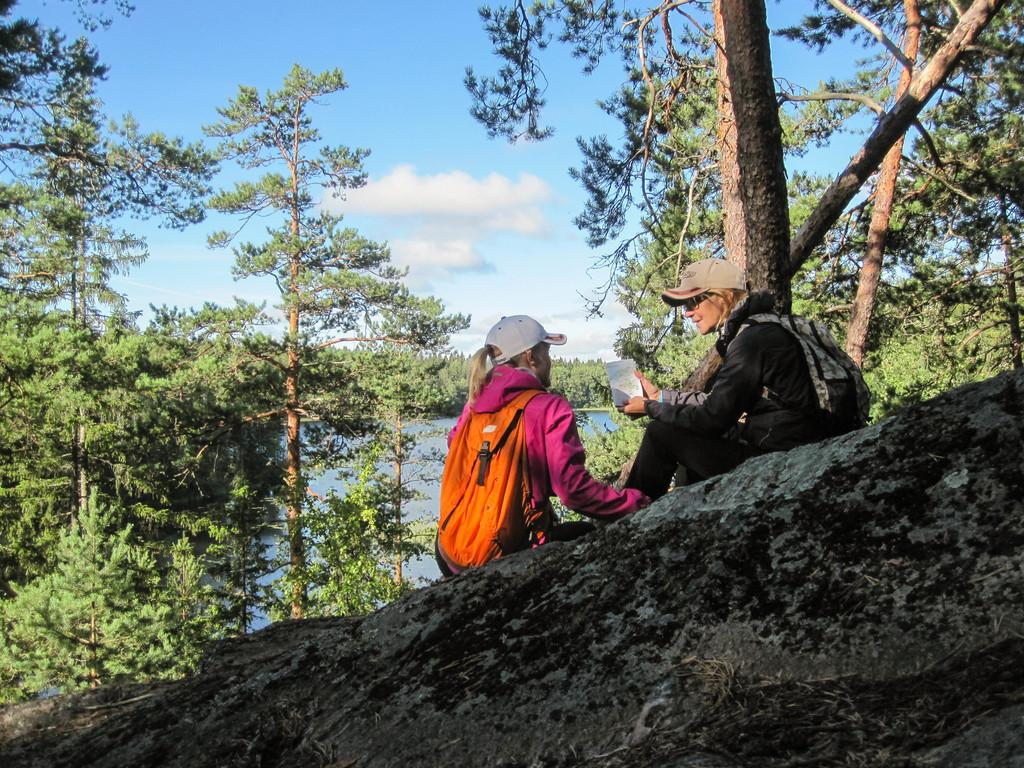How many women are in the image? There are two women in the image. What are the women doing in the image? The women are carrying bags and sitting on a rock. What can be seen in the background of the image? There are trees and the sky visible in the background of the image. What is the condition of the sky in the image? Clouds are present in the sky. What is the number of attempts the women made to climb the rock in the image? There is no indication in the image that the women attempted to climb the rock, as they are already sitting on it. 